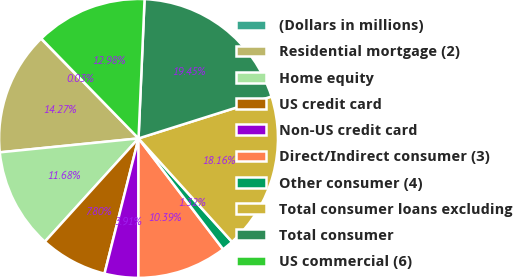Convert chart to OTSL. <chart><loc_0><loc_0><loc_500><loc_500><pie_chart><fcel>(Dollars in millions)<fcel>Residential mortgage (2)<fcel>Home equity<fcel>US credit card<fcel>Non-US credit card<fcel>Direct/Indirect consumer (3)<fcel>Other consumer (4)<fcel>Total consumer loans excluding<fcel>Total consumer<fcel>US commercial (6)<nl><fcel>0.03%<fcel>14.27%<fcel>11.68%<fcel>7.8%<fcel>3.91%<fcel>10.39%<fcel>1.32%<fcel>18.16%<fcel>19.45%<fcel>12.98%<nl></chart> 